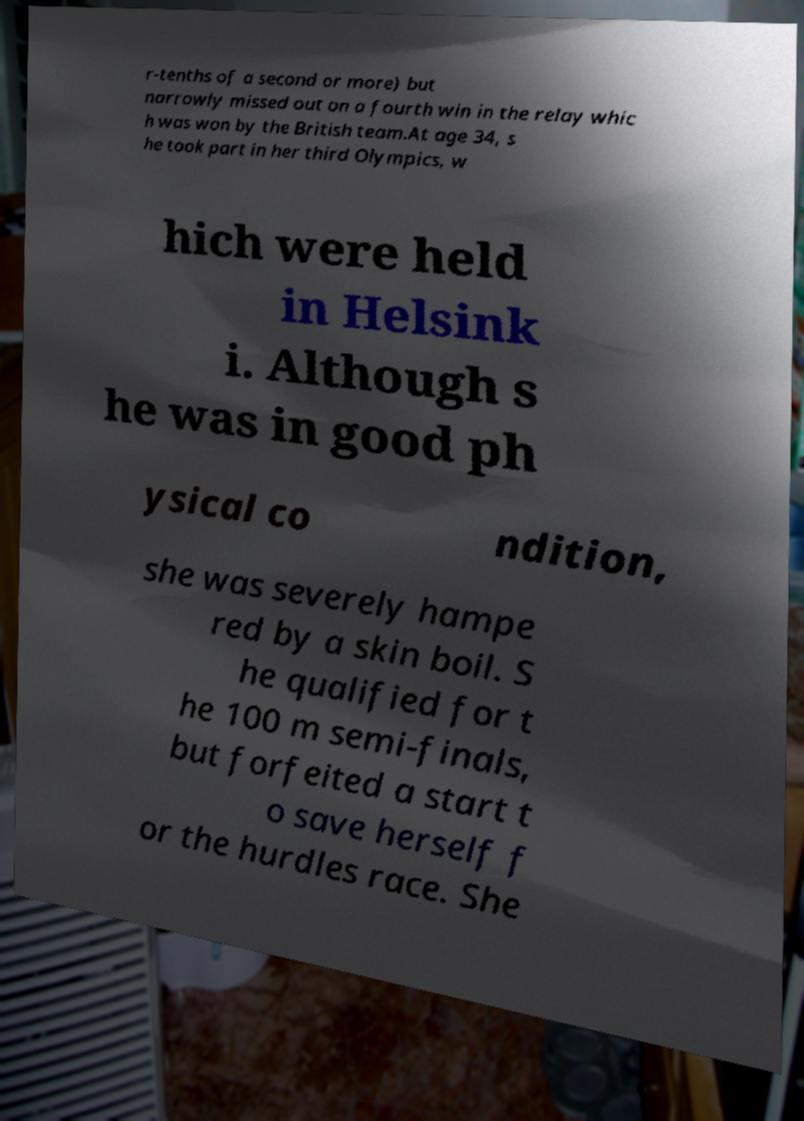Please read and relay the text visible in this image. What does it say? r-tenths of a second or more) but narrowly missed out on a fourth win in the relay whic h was won by the British team.At age 34, s he took part in her third Olympics, w hich were held in Helsink i. Although s he was in good ph ysical co ndition, she was severely hampe red by a skin boil. S he qualified for t he 100 m semi-finals, but forfeited a start t o save herself f or the hurdles race. She 